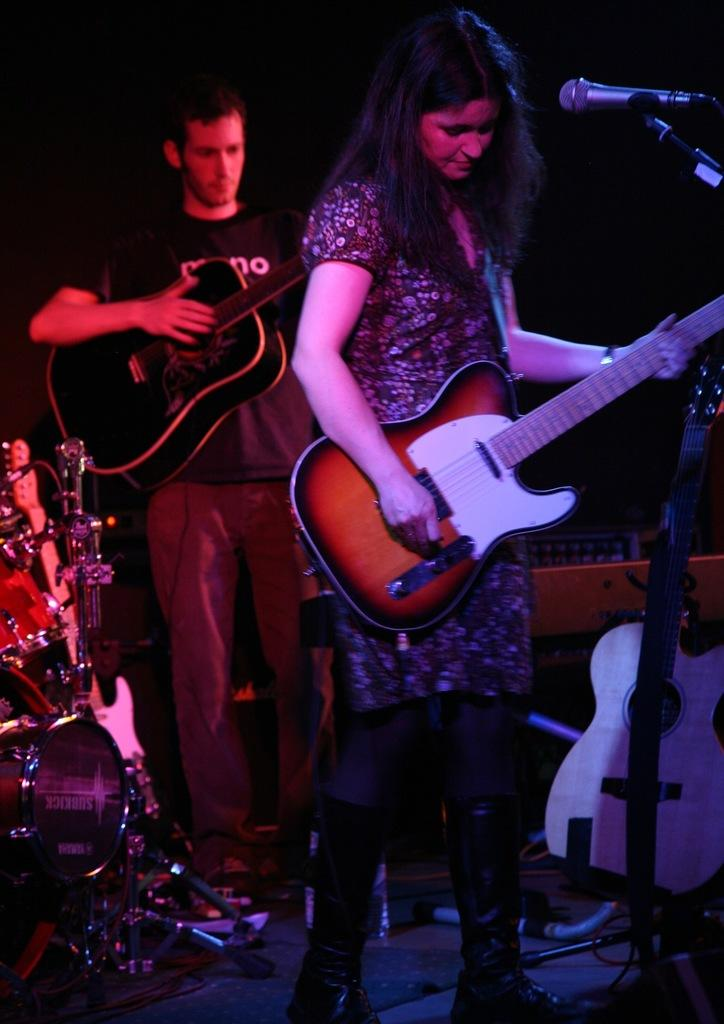How many people are in the image? There are two people in the image, a man and a woman. What are the man and the woman doing in the image? Both the man and the woman are standing and holding guitars. What other objects related to music can be seen in the image? There is a microphone and additional musical instruments in the image. What type of fuel is being used to power the instruments in the image? There is no fuel present in the image, as the instruments are not powered by any fuel. 